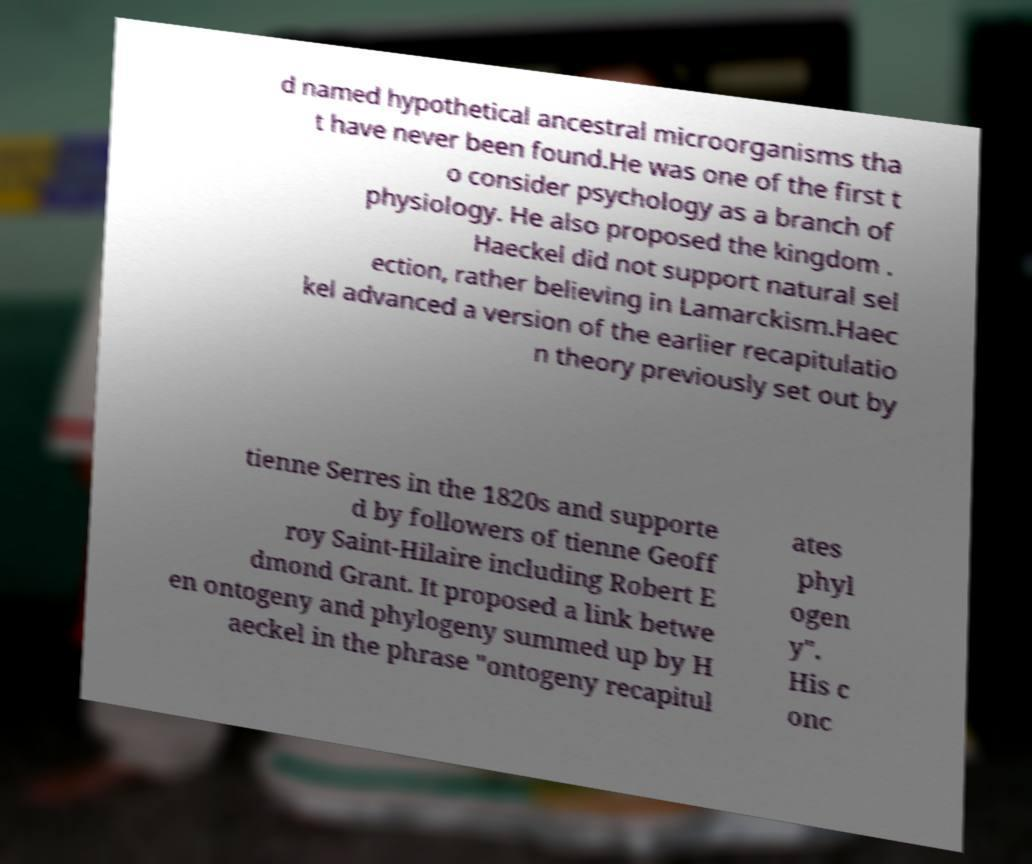Please identify and transcribe the text found in this image. d named hypothetical ancestral microorganisms tha t have never been found.He was one of the first t o consider psychology as a branch of physiology. He also proposed the kingdom . Haeckel did not support natural sel ection, rather believing in Lamarckism.Haec kel advanced a version of the earlier recapitulatio n theory previously set out by tienne Serres in the 1820s and supporte d by followers of tienne Geoff roy Saint-Hilaire including Robert E dmond Grant. It proposed a link betwe en ontogeny and phylogeny summed up by H aeckel in the phrase "ontogeny recapitul ates phyl ogen y". His c onc 